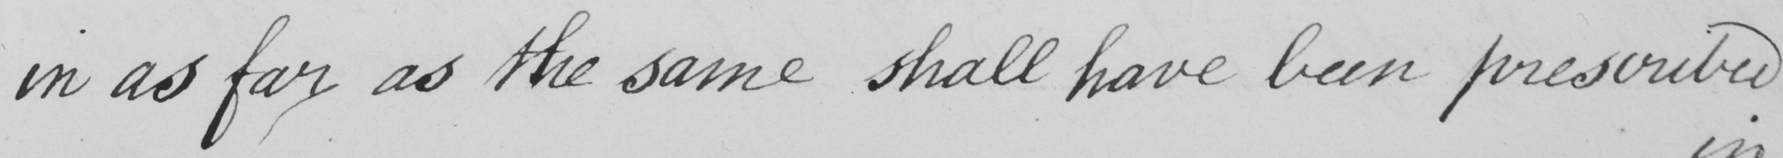What text is written in this handwritten line? in as far as the same shall have been prescribed 